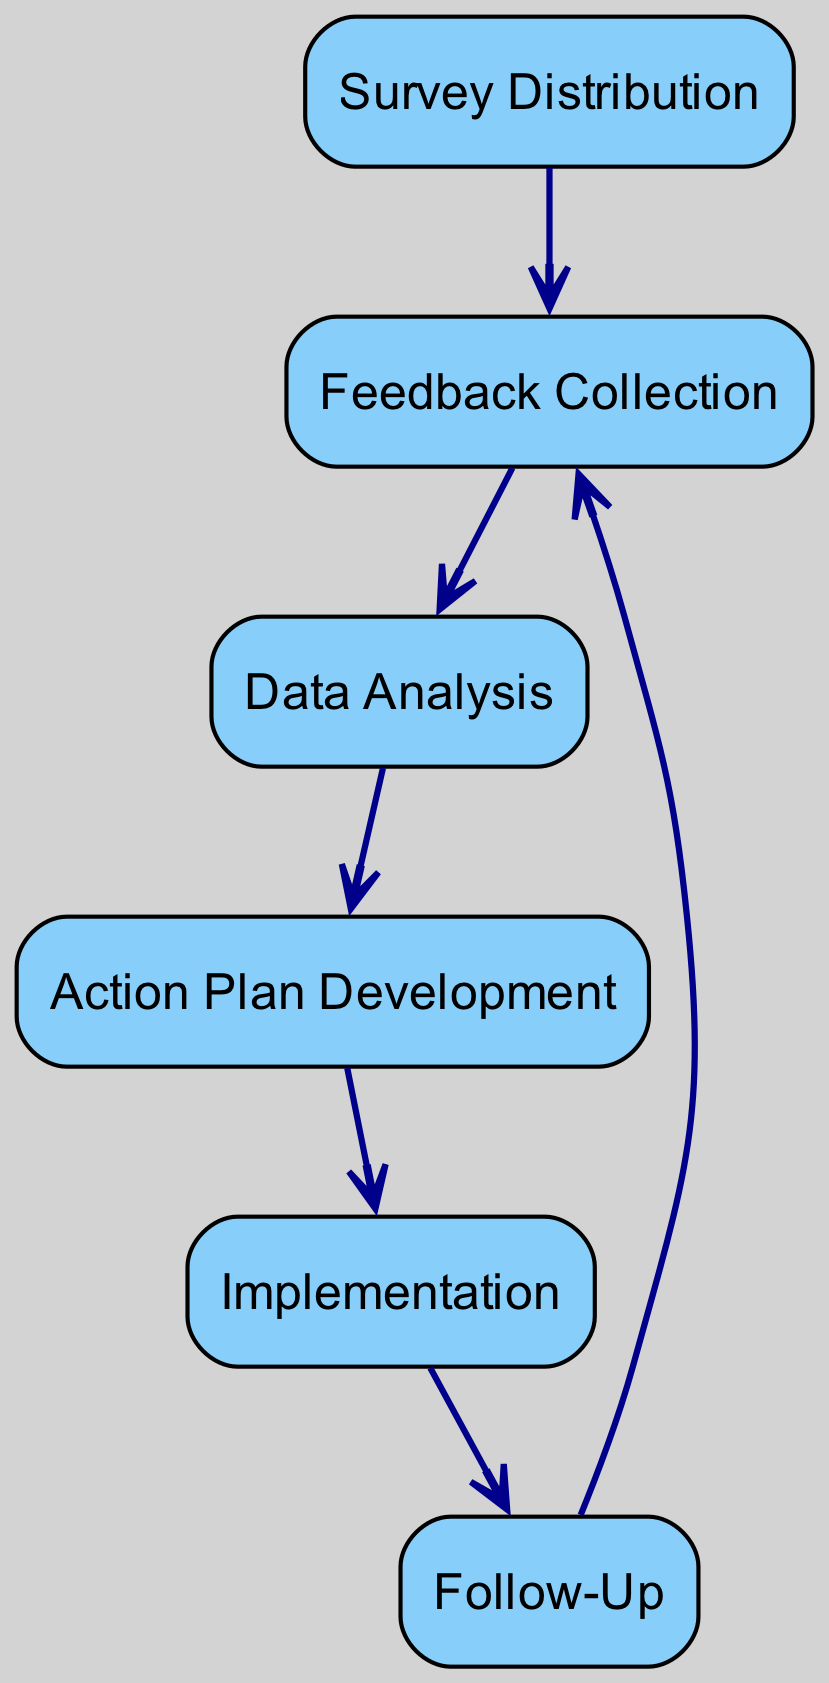What is the first step in collecting feedback from protest participants? The first step, as shown in the diagram, is "Survey Distribution," which involves handing out surveys to gather information on inclusivity and diversity post-events.
Answer: Survey Distribution How many nodes are present in the diagram? To determine the number of nodes, we count each of the distinct labeled elements representing different parts of the feedback loop. In total, there are six nodes in the diagram.
Answer: 6 What does the relationship between "followUp" and "feedbackCollection" signify? The directed edge from "followUp" to "feedbackCollection" indicates that after follow-up discussions and surveys, feedback is again collected, creating a continuous loop in the feedback process.
Answer: Continuous feedback loop Which step comes immediately before "actionPlanDevelopment"? The step immediately preceding "actionPlanDevelopment" is "dataAnalysis," which collects and examines the feedback gathered to inform the action plan.
Answer: Data Analysis What type of data is analyzed in "dataAnalysis"? The "dataAnalysis" step involves assessing the feedback data regarding inclusivity and diversity to detect identifiable trends, concerns, and suggestions from participants.
Answer: Feedback data Why is "implementation" essential in this process? "Implementation" is crucial as it refers to the execution of the changes developed in the action plan based on feedback, facilitating enhancements in protest organization and outreach in future events.
Answer: Execution of changes What sequence follows "implementation" according to the diagram? After "implementation," the sequence leads to "followUp," where further surveys or discussions are conducted to evaluate how effective the changes have been.
Answer: Follow-Up What is the relationship type that connects "surveyDistribution" and "feedbackCollection"? The relationship linking "surveyDistribution" to "feedbackCollection" is a directed edge that indicates the flow from distributing surveys to collecting feedback, establishing the start of the feedback loop process.
Answer: Directed edge Which step is related to assessing the effectiveness of implemented changes? The step that focuses on assessing the effectiveness of the changes made is "followUp," where additional surveys and discussions are held post-implementation.
Answer: Follow-Up 